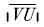Convert formula to latex. <formula><loc_0><loc_0><loc_500><loc_500>| \overline { V U } |</formula> 